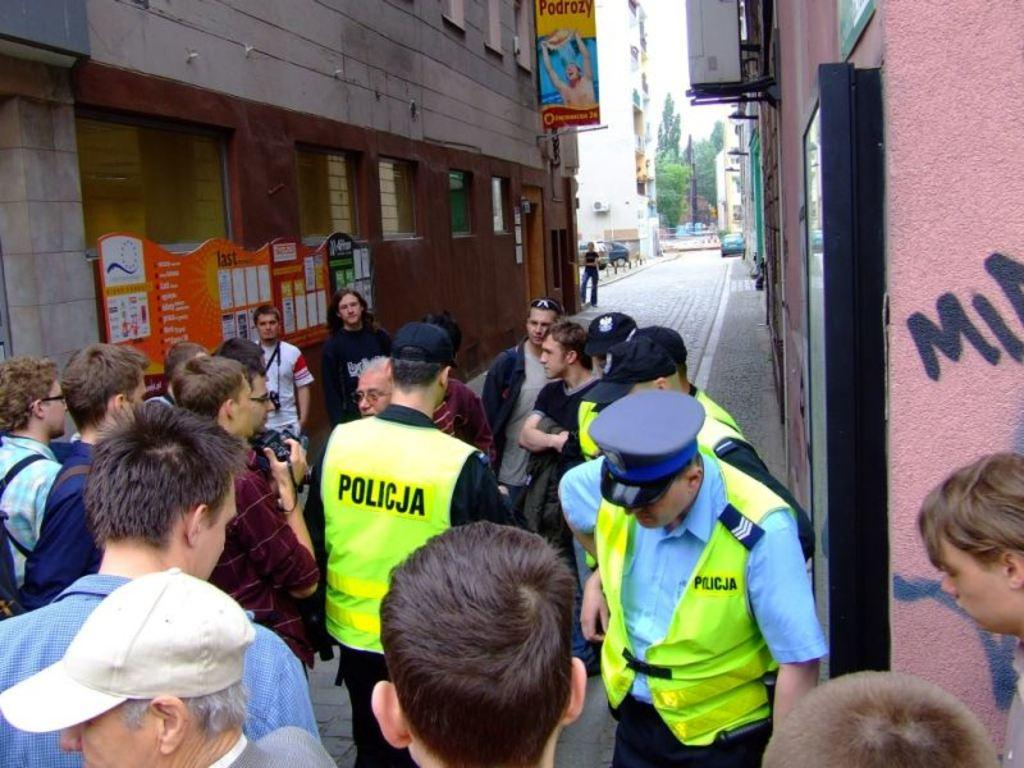How many people are in the image? There are people in the image, but the exact number is not specified. What is one person doing in the image? One person is holding a camera. What can be seen in the background of the image? There are buildings, windows, trees, and boards visible in the background. What type of transportation is visible on the road? Vehicles are visible on the road. Can you see a goose balancing on a cactus in the image? No, there is no goose or cactus present in the image. 